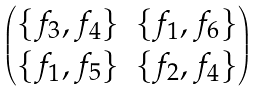<formula> <loc_0><loc_0><loc_500><loc_500>\begin{pmatrix} \{ f _ { 3 } , f _ { 4 } \} & \{ f _ { 1 } , f _ { 6 } \} \\ \{ f _ { 1 } , f _ { 5 } \} & \{ f _ { 2 } , f _ { 4 } \} \end{pmatrix}</formula> 